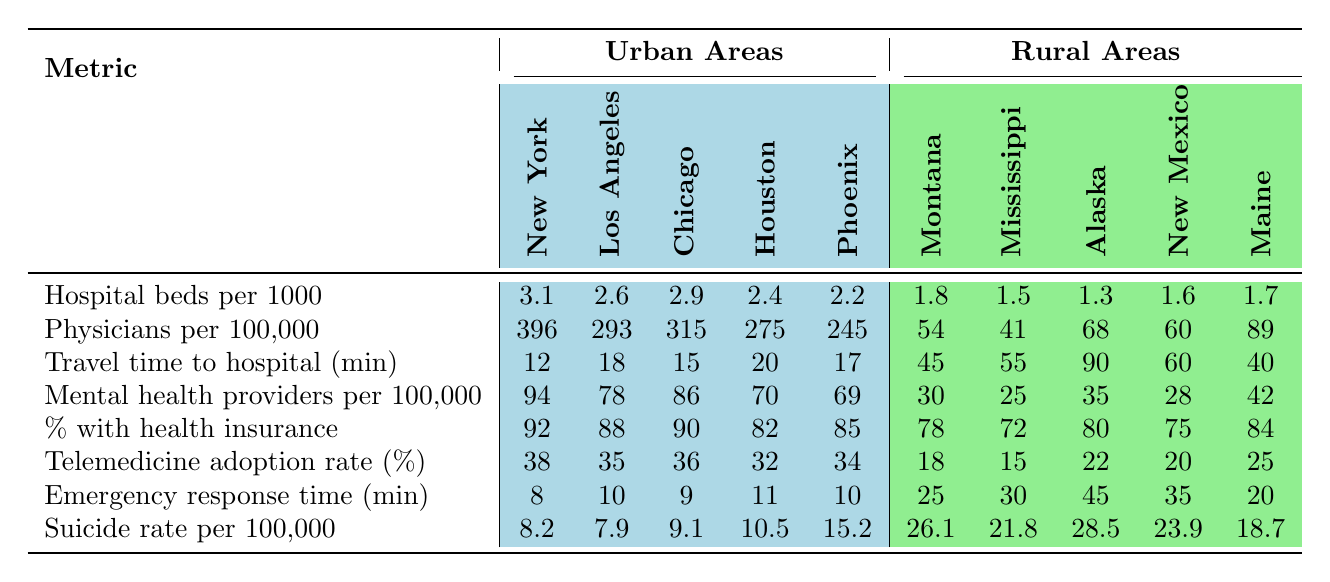What is the number of hospital beds per 1000 people in New York City? In the table, New York City has a value listed under the "Hospital beds per 1000" metric, which is 3.1.
Answer: 3.1 What is the average travel time to the nearest hospital in rural areas? To find the average travel time in rural areas, we add the travel times (45 + 55 + 90 + 60 + 40) = 290 and then divide by the number of rural areas (5), which gives us 290/5 = 58.
Answer: 58 Which urban area has the highest number of physicians per 100,000 people? By looking at the "Physicians per 100,000" row for urban areas, Los Angeles has the highest value at 396.
Answer: 396 Is the mental health provider availability lower in rural Arkansas compared to any urban area? No, Rural Arkansas is not listed in the table; thus, we refer to the metrics for rural areas, and all values for mental health providers in these areas (30, 25, 35, 28, 42) are lower than urban areas, with the highest urban value being 94 in New York City.
Answer: No What is the difference in suicide rates between rural Montana and New York City? The suicide rate for Rural Montana is 26.1 and for New York City it is 8.2, subtracting these gives us 26.1 - 8.2 = 17.9.
Answer: 17.9 Which location has the quickest emergency response time, and how long is it? By comparing the emergency response time values, New York City reports the lowest time of 8 minutes, qualifying it as the quickest.
Answer: 8 minutes What percentage of the population in rural areas has health insurance compared to urban Phoenix? Urban Phoenix has a health insurance rate of 85%, and the average health insurance rate for rural areas is calculated from (78 + 72 + 80 + 75 + 84) = 389, then dividing by 5 gives approximately 77.8%. Comparing both, rural areas have lower health insurance coverage.
Answer: Yes, rural areas have lower insurance What is the range of the number of emergency response times across the urban locations? The maximum response time in urban areas is 20 minutes (Houston), and the minimum is 8 minutes (New York City). Therefore, the range is calculated as 20 - 8 = 12 minutes.
Answer: 12 minutes If you were to normalize the telemedicine adoption rate for urban areas, what would be the average value? Summing the urban telemedicine adoption rates: (38 + 35 + 36 + 32 + 34) = 175, then dividing by 5 gives 175/5 = 35.
Answer: 35 How does the ratio of hospital beds per capita differ between urban and rural areas? For urban areas, the average is (3.1 + 2.6 + 2.9 + 2.4 + 2.2) / 5 = 2.86 beds per 1000 people. For rural areas, the average is (1.8 + 1.5 + 1.3 + 1.6 + 1.7) / 5 = 1.58. Thus, urban areas have a higher ratio.
Answer: Urban areas have a higher ratio 